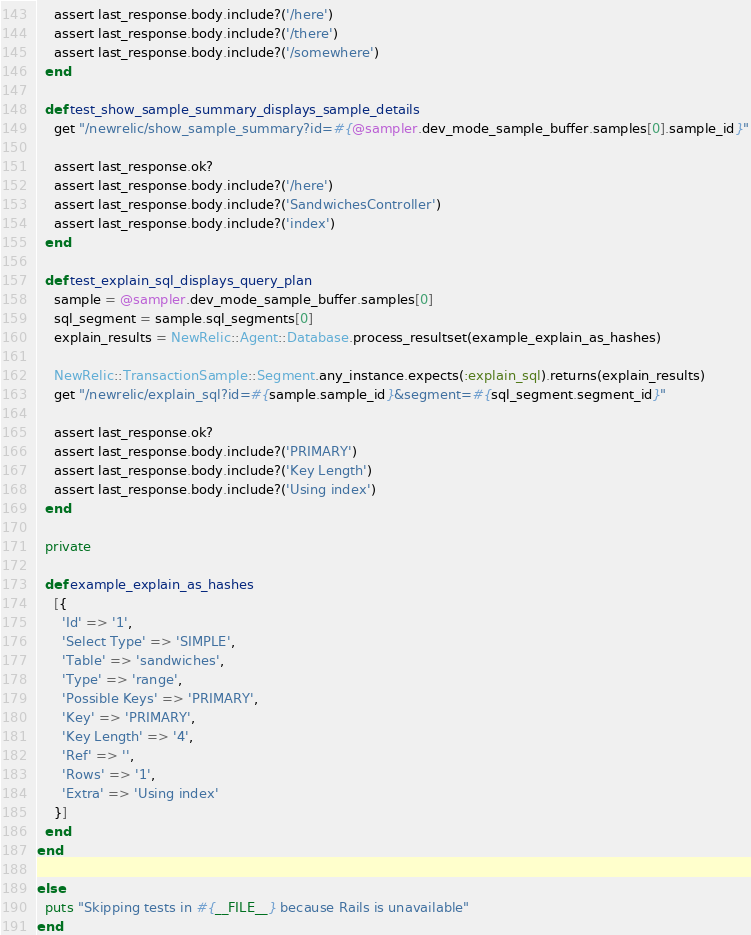Convert code to text. <code><loc_0><loc_0><loc_500><loc_500><_Ruby_>    assert last_response.body.include?('/here')
    assert last_response.body.include?('/there')
    assert last_response.body.include?('/somewhere')
  end

  def test_show_sample_summary_displays_sample_details
    get "/newrelic/show_sample_summary?id=#{@sampler.dev_mode_sample_buffer.samples[0].sample_id}"

    assert last_response.ok?
    assert last_response.body.include?('/here')
    assert last_response.body.include?('SandwichesController')
    assert last_response.body.include?('index')
  end

  def test_explain_sql_displays_query_plan
    sample = @sampler.dev_mode_sample_buffer.samples[0]
    sql_segment = sample.sql_segments[0]
    explain_results = NewRelic::Agent::Database.process_resultset(example_explain_as_hashes)

    NewRelic::TransactionSample::Segment.any_instance.expects(:explain_sql).returns(explain_results)
    get "/newrelic/explain_sql?id=#{sample.sample_id}&segment=#{sql_segment.segment_id}"

    assert last_response.ok?
    assert last_response.body.include?('PRIMARY')
    assert last_response.body.include?('Key Length')
    assert last_response.body.include?('Using index')
  end

  private

  def example_explain_as_hashes
    [{
      'Id' => '1',
      'Select Type' => 'SIMPLE',
      'Table' => 'sandwiches',
      'Type' => 'range',
      'Possible Keys' => 'PRIMARY',
      'Key' => 'PRIMARY',
      'Key Length' => '4',
      'Ref' => '',
      'Rows' => '1',
      'Extra' => 'Using index'
    }]
  end
end

else
  puts "Skipping tests in #{__FILE__} because Rails is unavailable"
end
</code> 